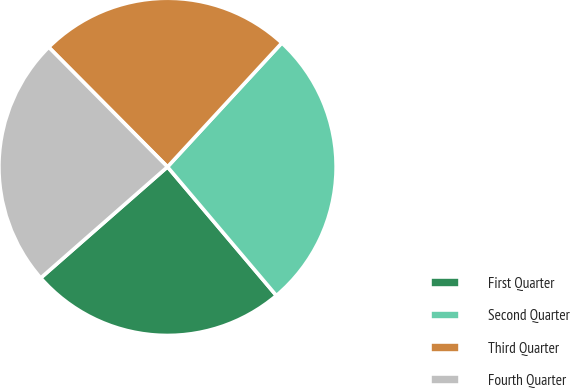Convert chart. <chart><loc_0><loc_0><loc_500><loc_500><pie_chart><fcel>First Quarter<fcel>Second Quarter<fcel>Third Quarter<fcel>Fourth Quarter<nl><fcel>24.72%<fcel>26.97%<fcel>24.3%<fcel>24.01%<nl></chart> 